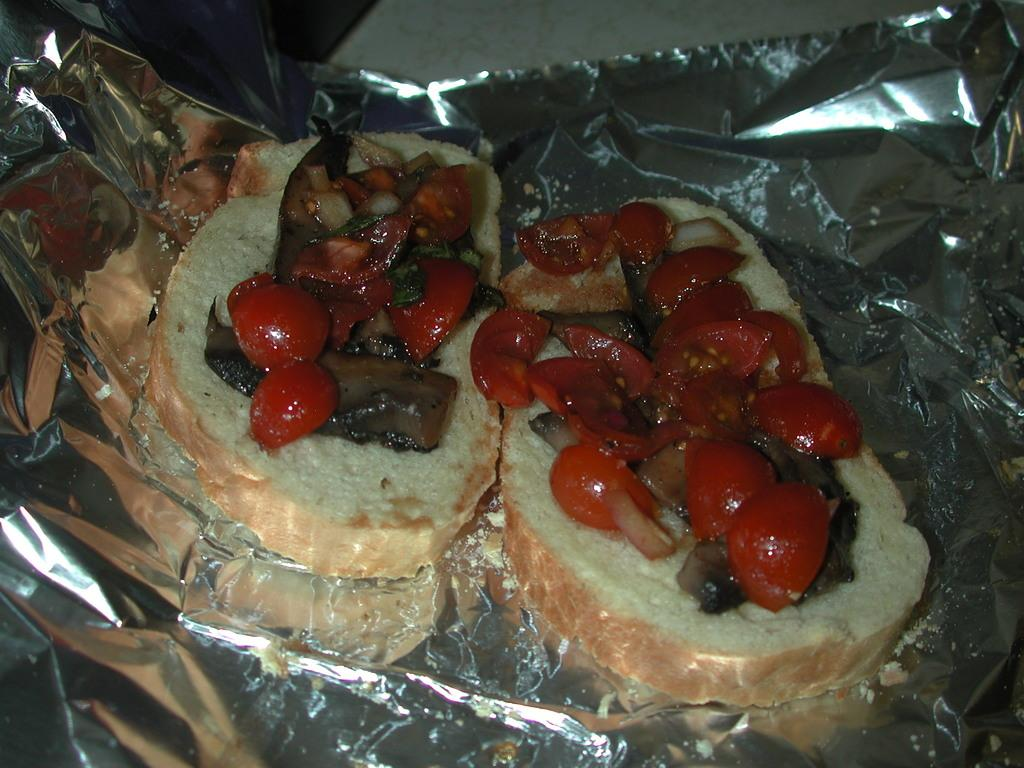What is located at the bottom of the image? There is a cover at the bottom of the image. What is on top of the cover? There is food on the cover. What type of border can be seen around the cover in the image? There is no mention of a border in the provided facts, so it cannot be determined from the image. 